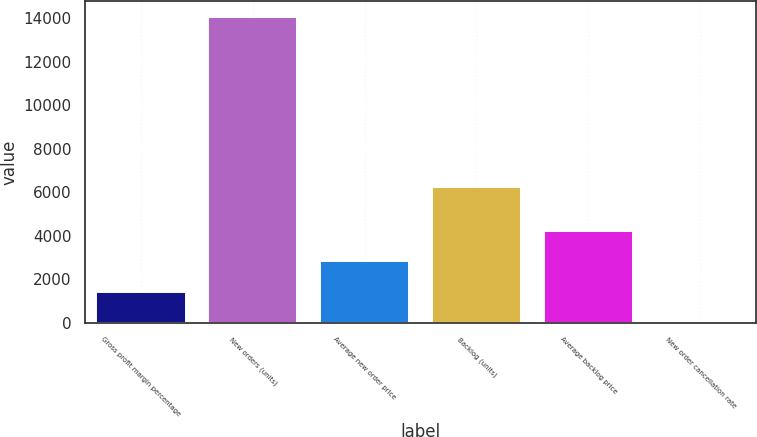Convert chart. <chart><loc_0><loc_0><loc_500><loc_500><bar_chart><fcel>Gross profit margin percentage<fcel>New orders (units)<fcel>Average new order price<fcel>Backlog (units)<fcel>Average backlog price<fcel>New order cancellation rate<nl><fcel>1421.05<fcel>14080<fcel>2827.6<fcel>6229<fcel>4234.15<fcel>14.5<nl></chart> 